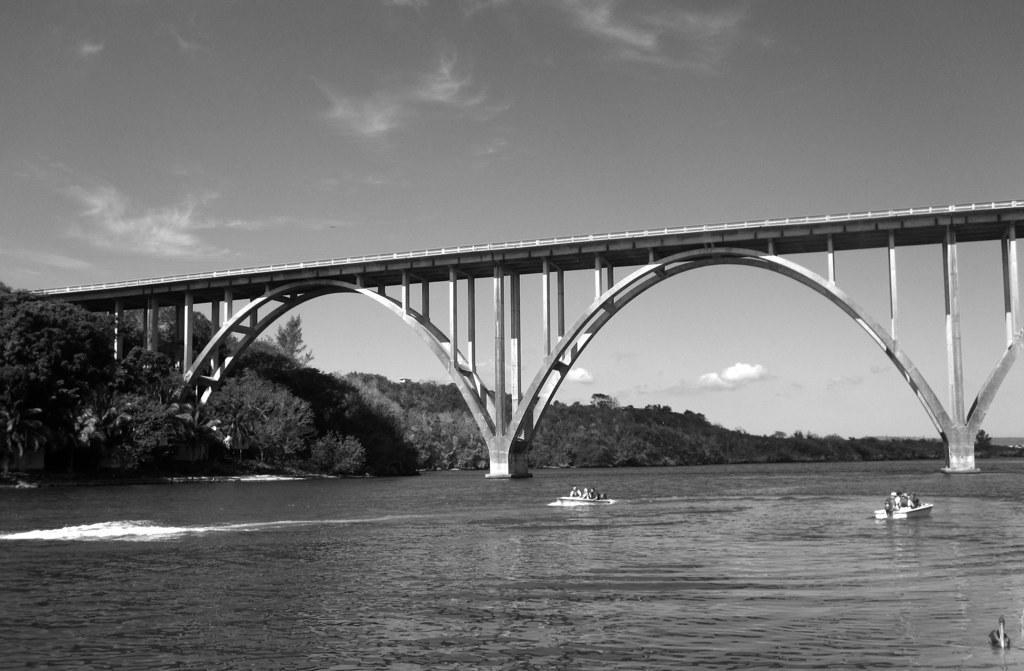Please provide a concise description of this image. At the bottom of this image there is a river. On the right side, I can see few people in the boats. In the background, I can see a bridge and many trees. At the top I can see the sky. In the bottom right I can see a bird on the water. This is a black and white image. 